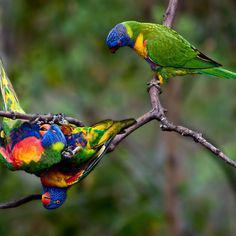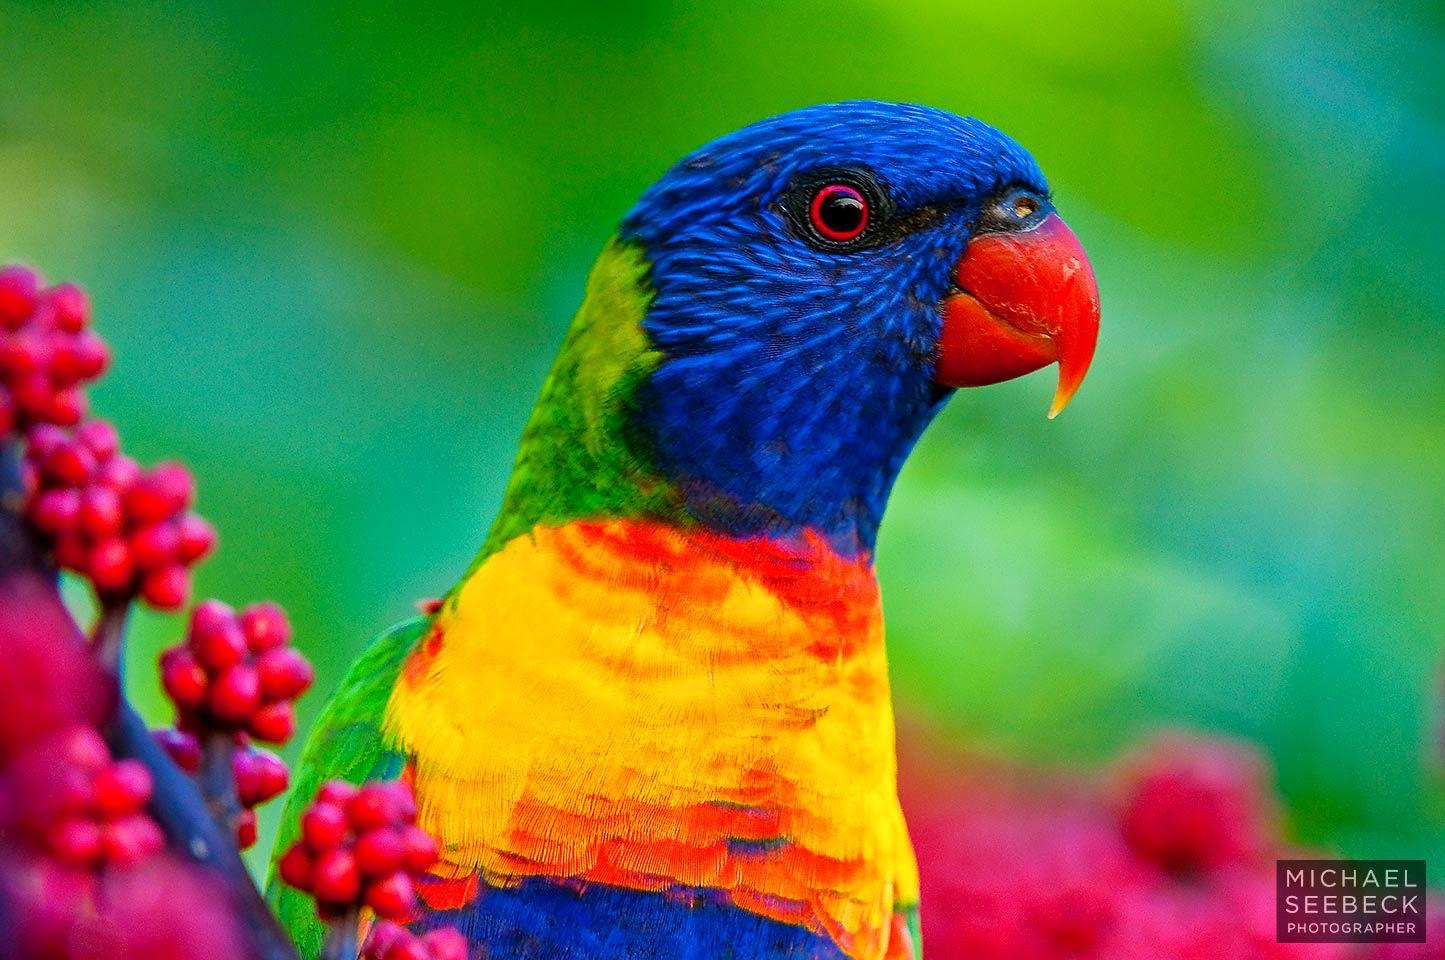The first image is the image on the left, the second image is the image on the right. Given the left and right images, does the statement "Part of a human is pictured with a single bird in one of the images." hold true? Answer yes or no. No. The first image is the image on the left, the second image is the image on the right. Considering the images on both sides, is "One bird is upside down." valid? Answer yes or no. Yes. 